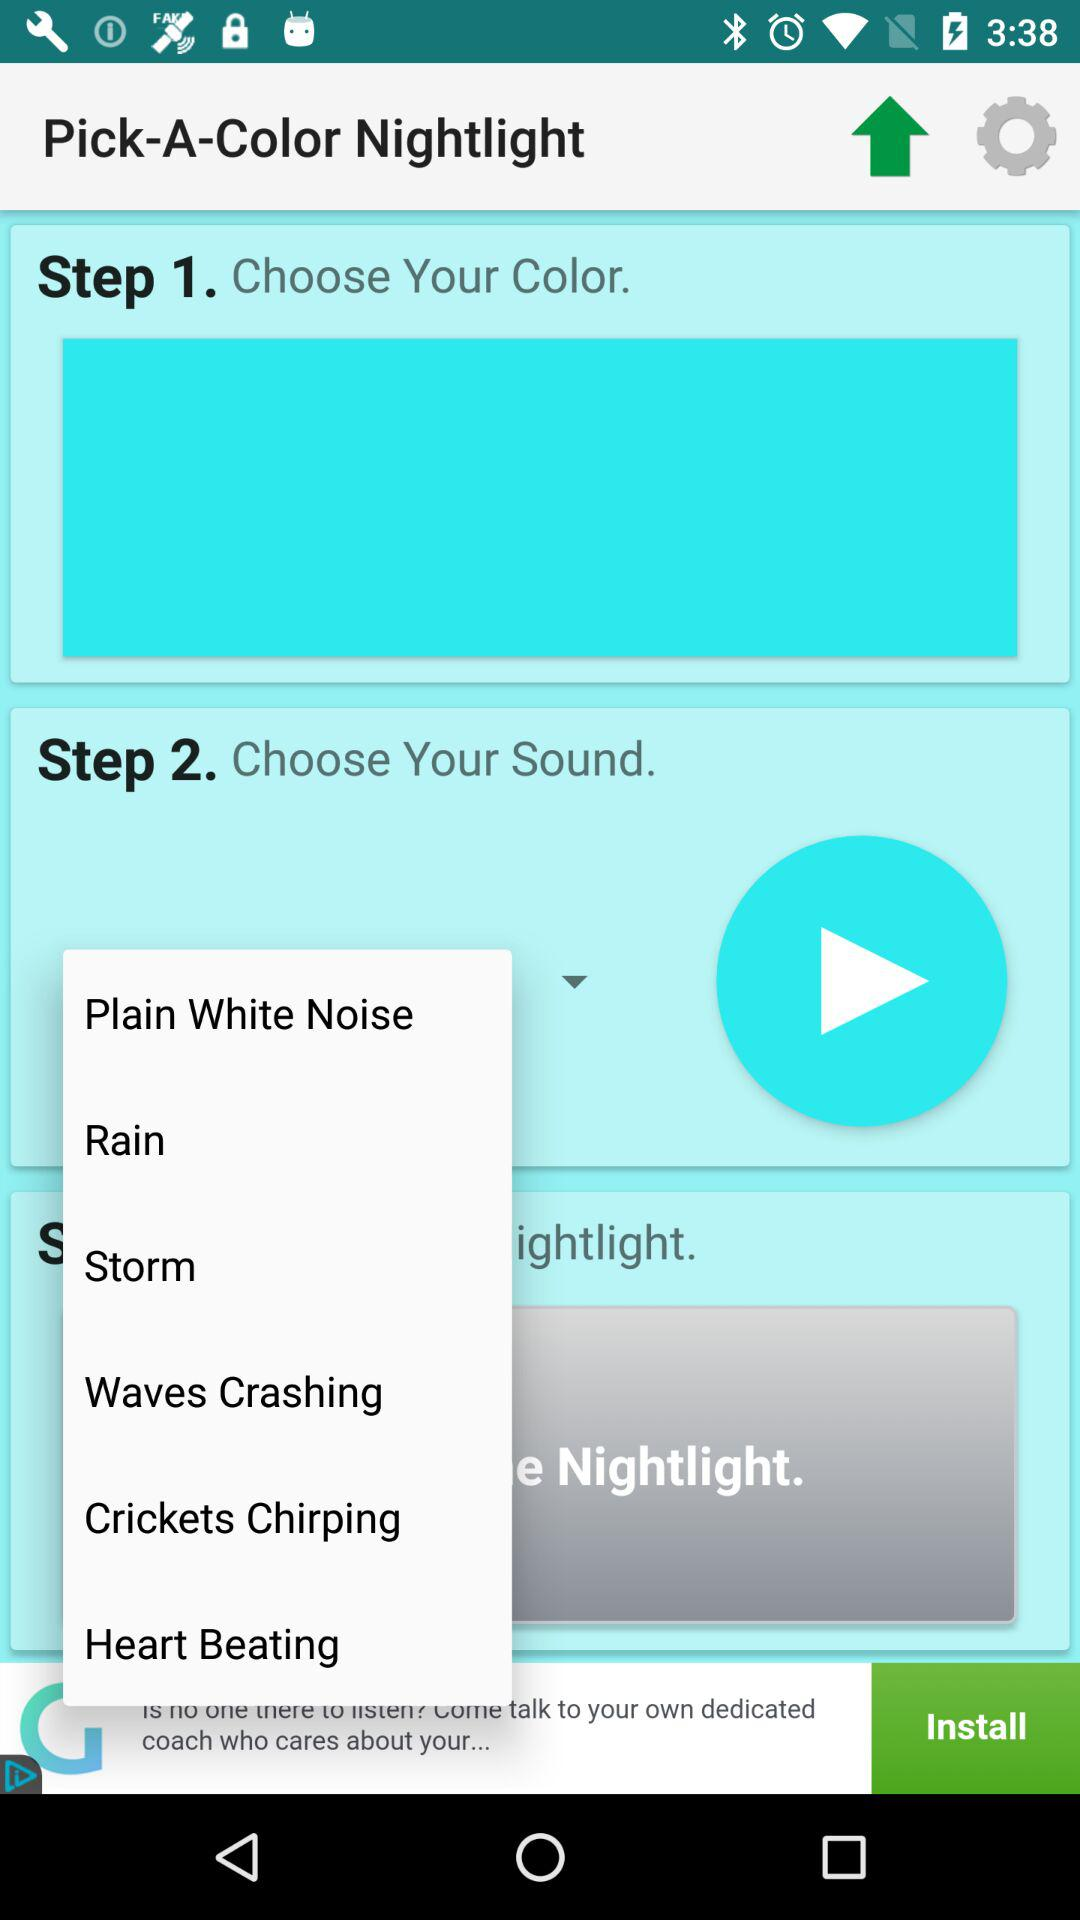What to choose at step 1? At step 1, choose the color. 